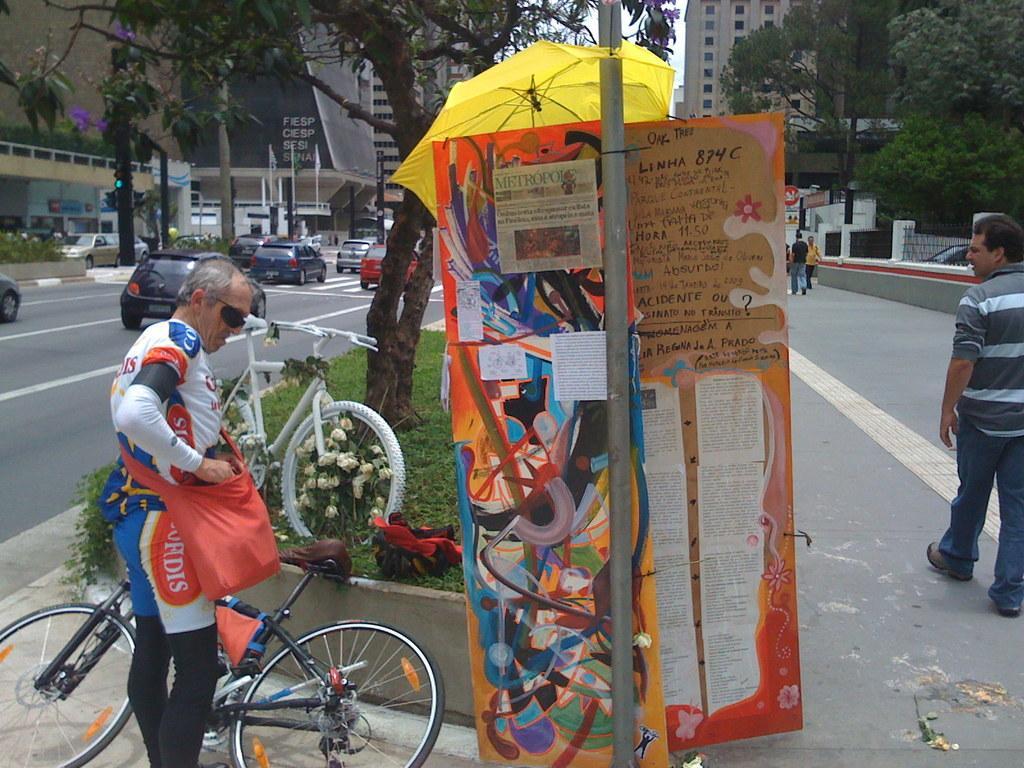How would you summarize this image in a sentence or two? In this image i can see a group of people are walking on the road and few vehicles on the road. I can also see there are few buildings and trees. 